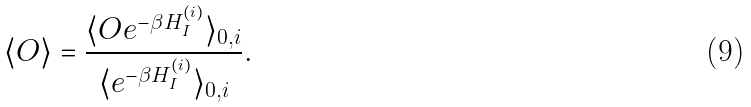<formula> <loc_0><loc_0><loc_500><loc_500>\langle O \rangle = \frac { \langle O e ^ { - \beta H _ { I } ^ { ( i ) } } \rangle _ { 0 , i } } { \langle e ^ { - \beta H _ { I } ^ { ( i ) } } \rangle _ { 0 , i } } .</formula> 